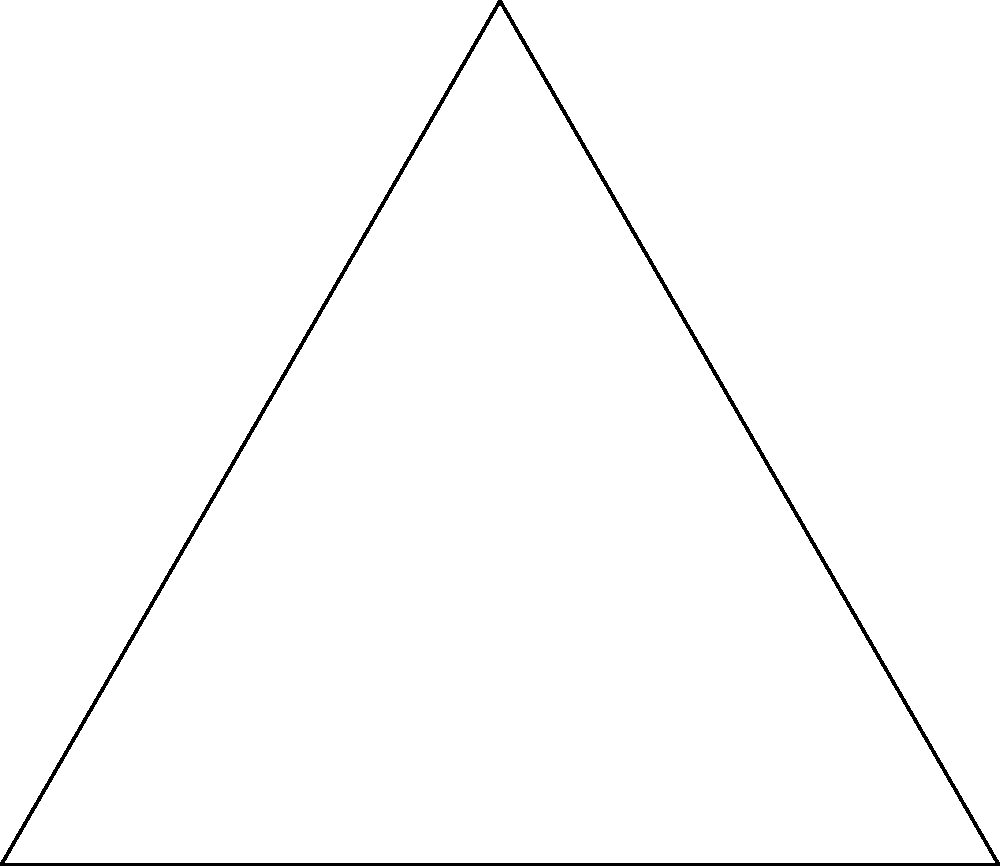In your role as a healthcare advocate, you often use visual aids to explain complex concepts. Consider the diagram above showing an equilateral triangle with side length $s$ and an inscribed circle. If the side length of the triangle is 10 cm, what is the area of the inscribed circle? Round your answer to two decimal places. Let's approach this step-by-step:

1) In an equilateral triangle, the radius of the inscribed circle ($r$) is related to the side length ($s$) by the formula:

   $$r = \frac{s}{2\sqrt{3}}$$

2) Given that $s = 10$ cm, we can calculate $r$:

   $$r = \frac{10}{2\sqrt{3}} = \frac{5}{\sqrt{3}} \approx 2.89 \text{ cm}$$

3) The area of a circle is given by the formula $A = \pi r^2$

4) Substituting our value for $r$:

   $$A = \pi \left(\frac{5}{\sqrt{3}}\right)^2$$

5) Simplifying:

   $$A = \pi \cdot \frac{25}{3} \approx 26.18 \text{ cm}^2$$

6) Rounding to two decimal places:

   $$A \approx 26.18 \text{ cm}^2$$

This visual representation and calculation method can be used to explain how precise measurements and mathematical principles are crucial in healthcare, just as they are in pharmacy dosage calculations.
Answer: 26.18 cm² 